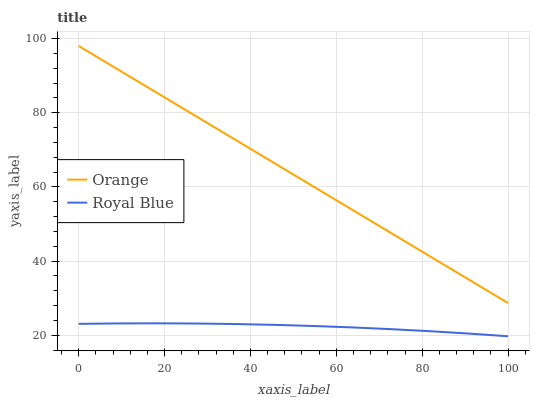Does Royal Blue have the minimum area under the curve?
Answer yes or no. Yes. Does Orange have the maximum area under the curve?
Answer yes or no. Yes. Does Royal Blue have the maximum area under the curve?
Answer yes or no. No. Is Orange the smoothest?
Answer yes or no. Yes. Is Royal Blue the roughest?
Answer yes or no. Yes. Is Royal Blue the smoothest?
Answer yes or no. No. Does Royal Blue have the lowest value?
Answer yes or no. Yes. Does Orange have the highest value?
Answer yes or no. Yes. Does Royal Blue have the highest value?
Answer yes or no. No. Is Royal Blue less than Orange?
Answer yes or no. Yes. Is Orange greater than Royal Blue?
Answer yes or no. Yes. Does Royal Blue intersect Orange?
Answer yes or no. No. 